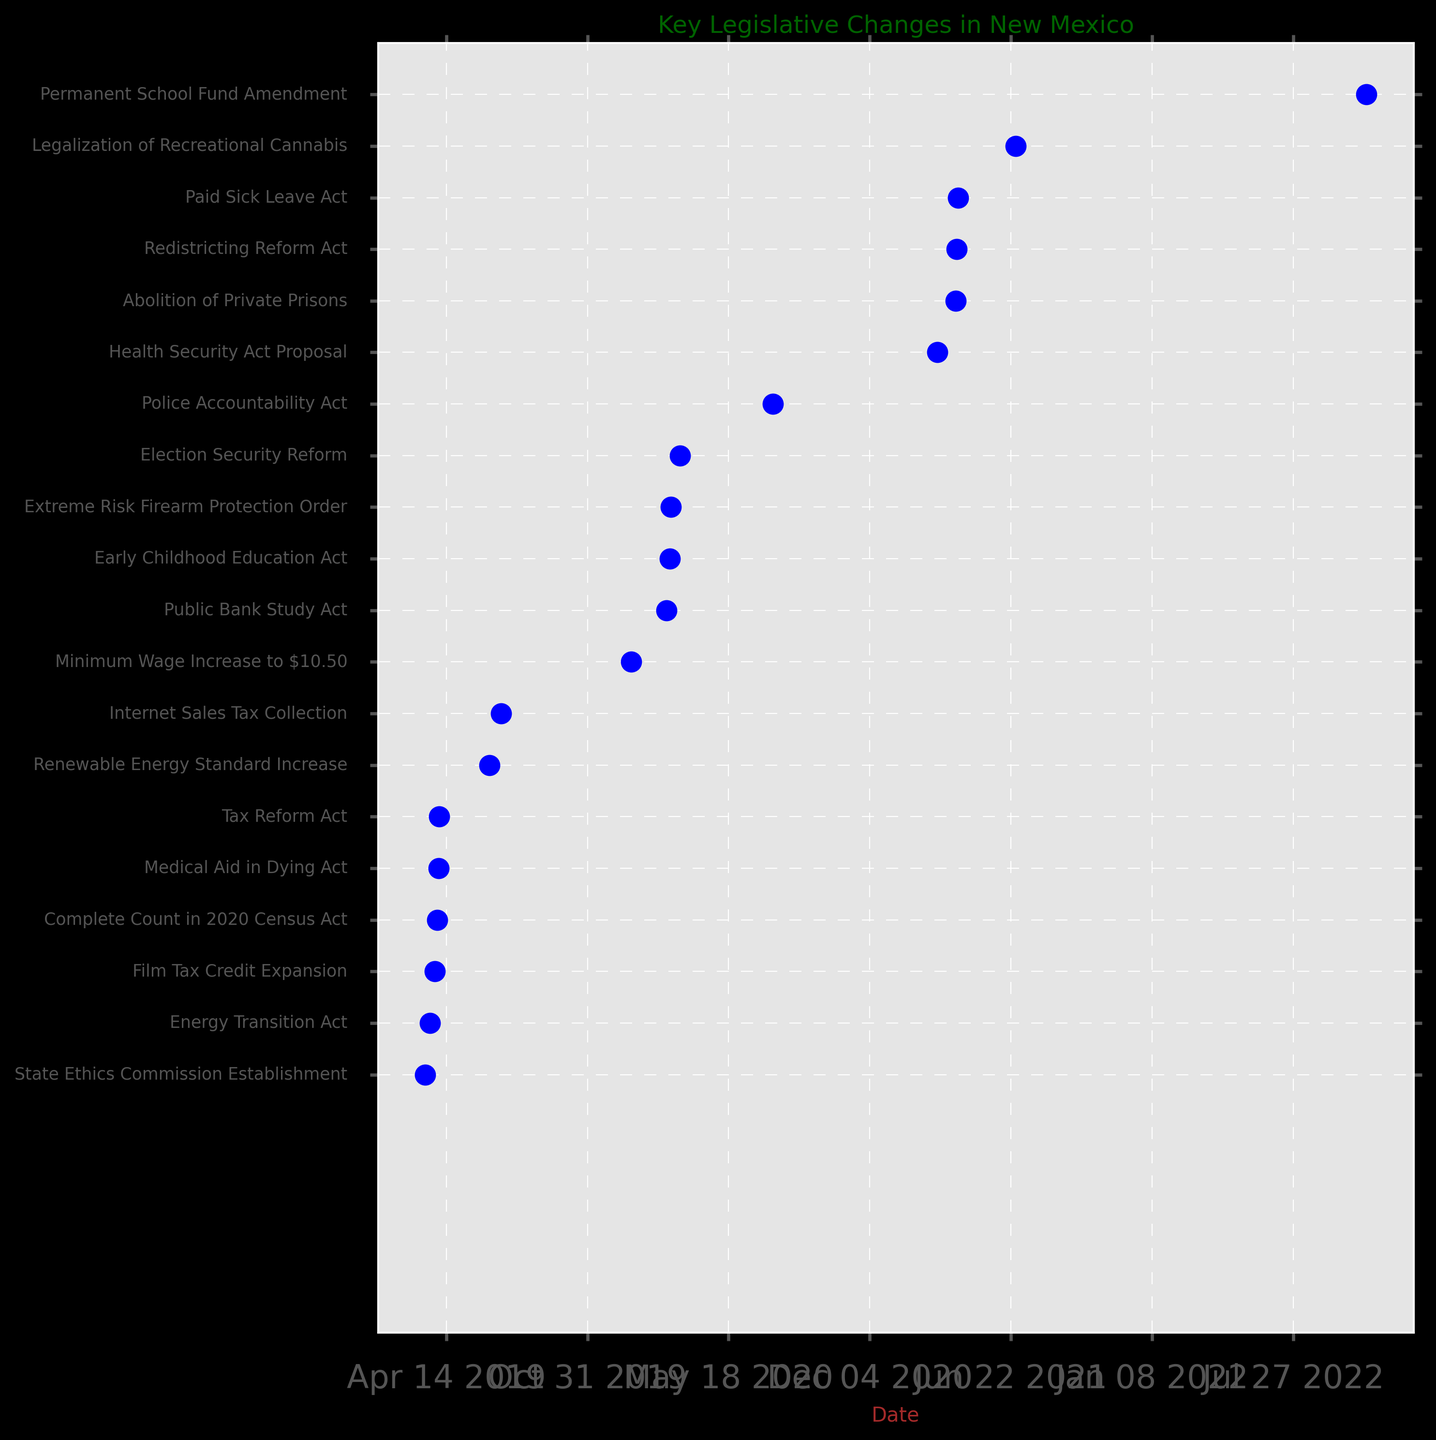Which legislative change was implemented most recently? By scanning the dates in the figure from right to left, the most recent date will correspond to the legislative change on the farthest right.
Answer: Permanent School Fund Amendment How many legislative changes were implemented in 2020? Identify all the dates marked in 2020. Count the number of events corresponding to the year 2020.
Answer: 6 Which was implemented earlier, the Energy Transition Act or the Medical Aid in Dying Act? Locate both legislative changes in the list. By comparing their positions, the one appearing earlier in the timeline had an earlier implementation date.
Answer: Energy Transition Act How long after the Energy Transition Act was the Renewable Energy Standard Increase enacted? Determine the dates of both acts and calculate the difference between them in days. The Energy Transition Act was implemented on 2019-03-22 and the Renewable Energy Standard Increase on 2019-06-14.
Answer: 84 days Which two legislative changes implemented in 2021 are closest in time to each other? Find the dates of all 2021 legislative changes. By calculating the date differences between each, identify the pair with the smallest difference.
Answer: Paid Sick Leave Act and Abolition of Private Prisons How many legislative changes were implemented before the Internet Sales Tax Collection? Identify the implementation date of the Internet Sales Tax Collection (2019-07-01) and count all legislative changes occurring before this date.
Answer: 6 Which event occurred earlier, the Film Tax Credit Expansion or the State Ethics Commission Establishment? Compare the positions of the two events and identify which one appears earlier in the timeline.
Answer: State Ethics Commission Establishment Are there more legislative changes before or after the Paid Sick Leave Act? Identify the date for the Paid Sick Leave Act (2021-04-08) and count the number of events before and after it. Compare the counts.
Answer: More before What is the time gap between the Election Security Reform and Police Accountability Act? Calculate the difference in days between their implementation dates (2020-03-10 and 2020-07-20).
Answer: 132 days Which legislative change happened in April, and what were their respective years? Look for all events that fall in April and check their years.
Answer: Redistricting Reform Act (2021), Paid Sick Leave Act (2021), Abolition of Private Prisons (2021), Medical Aid in Dying Act (2019), Tax Reform Act (2019) 